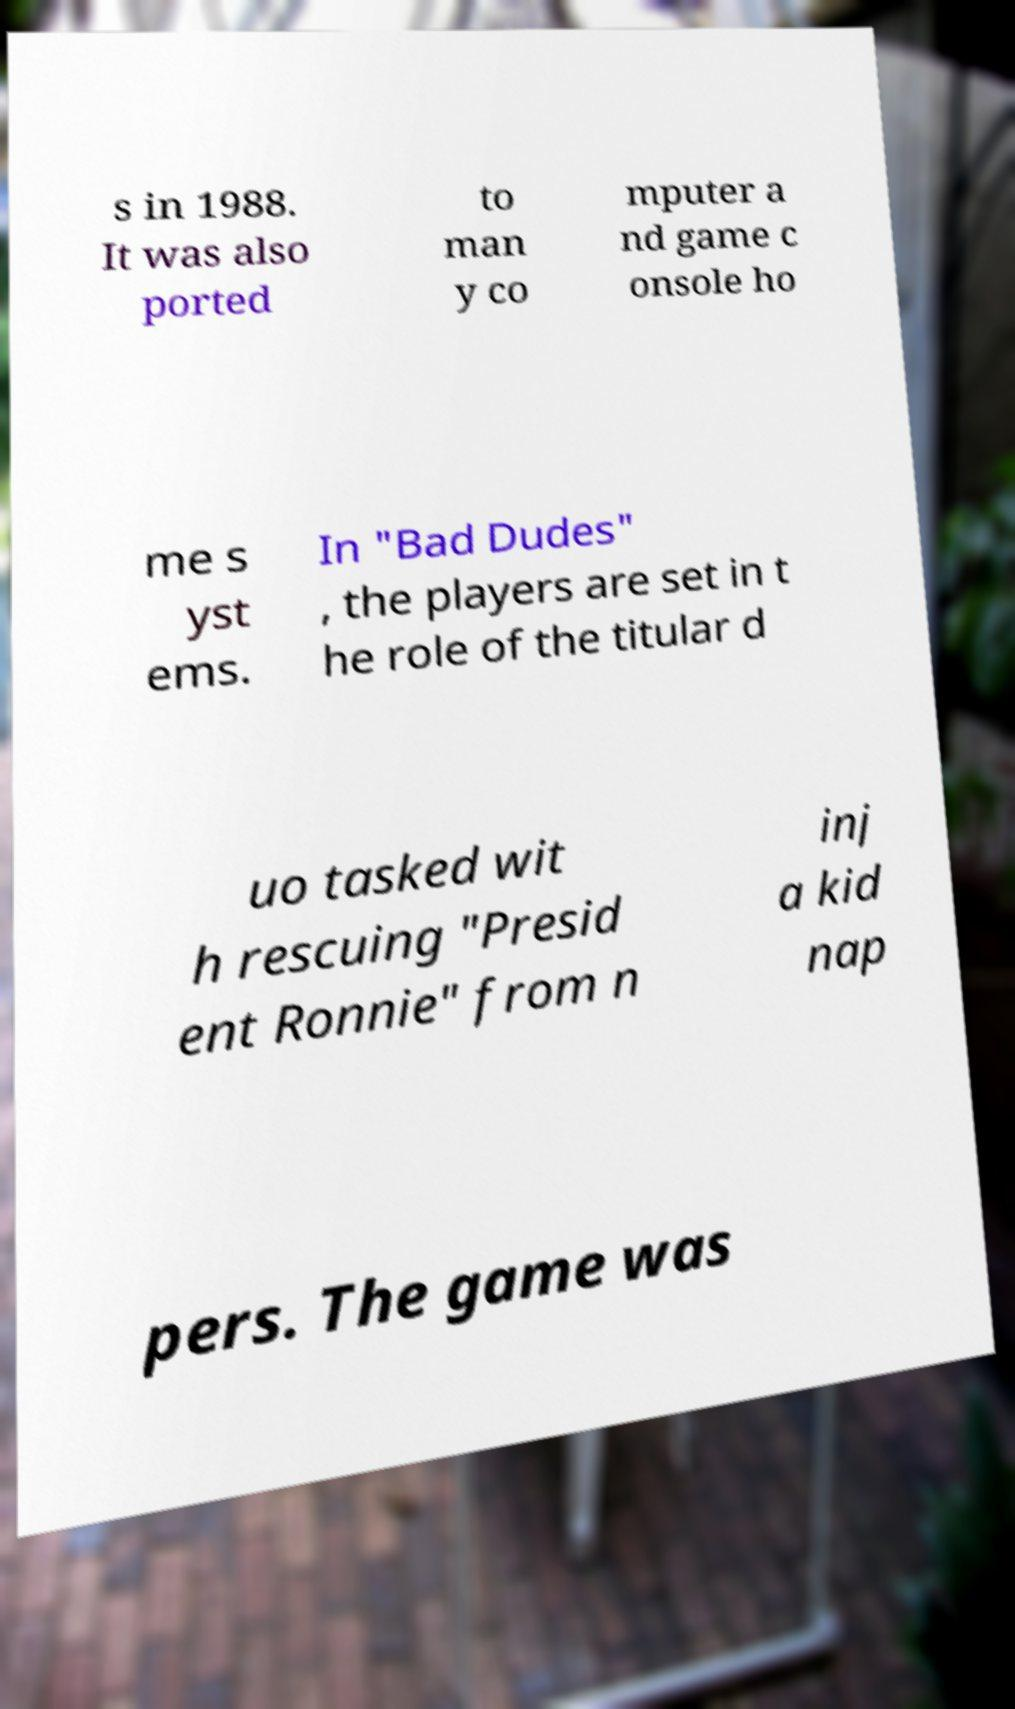For documentation purposes, I need the text within this image transcribed. Could you provide that? s in 1988. It was also ported to man y co mputer a nd game c onsole ho me s yst ems. In "Bad Dudes" , the players are set in t he role of the titular d uo tasked wit h rescuing "Presid ent Ronnie" from n inj a kid nap pers. The game was 